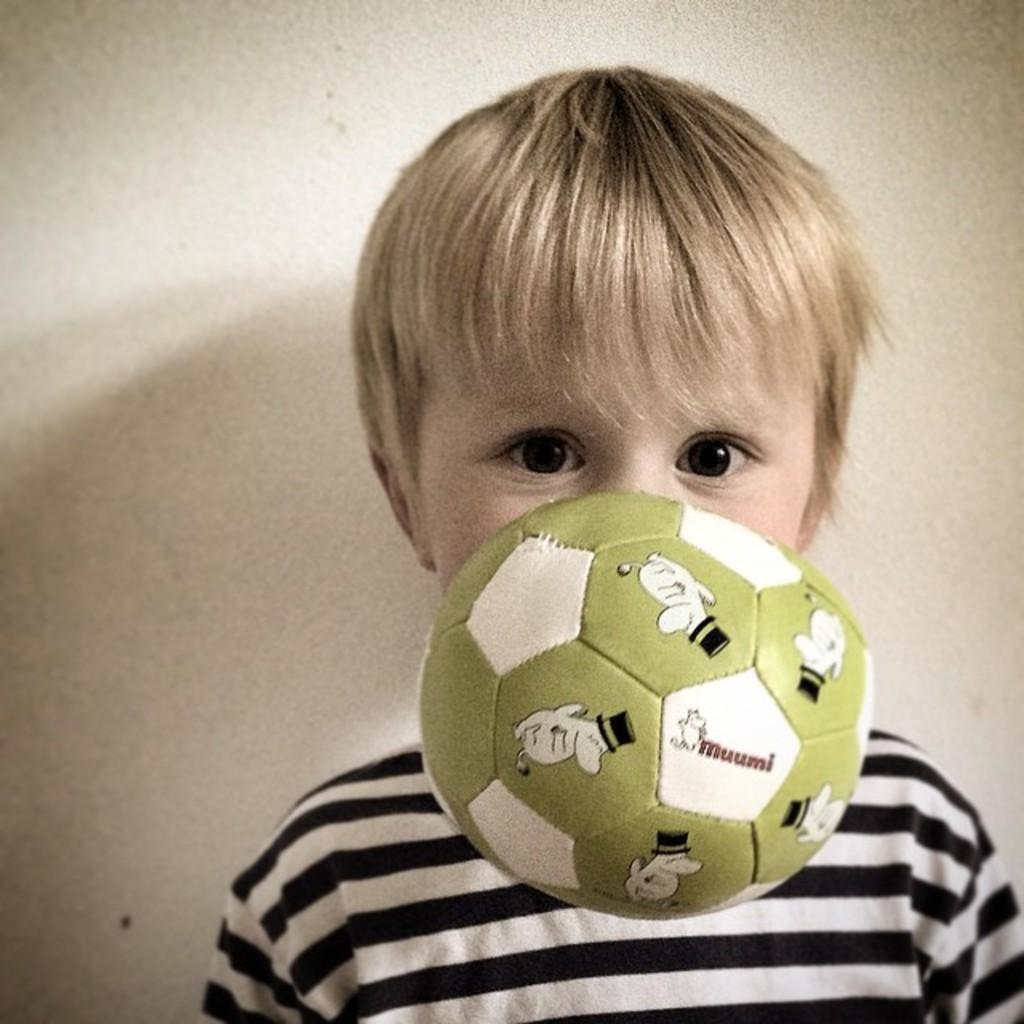Who is the main subject in the picture? There is a boy in the picture. What is the boy wearing? The boy is wearing a t-shirt. What object is located in the middle of the image? There is a football in the middle of the image. What type of pest can be seen crawling on the football in the image? There are no pests visible in the image, and no pests are crawling on the football. 